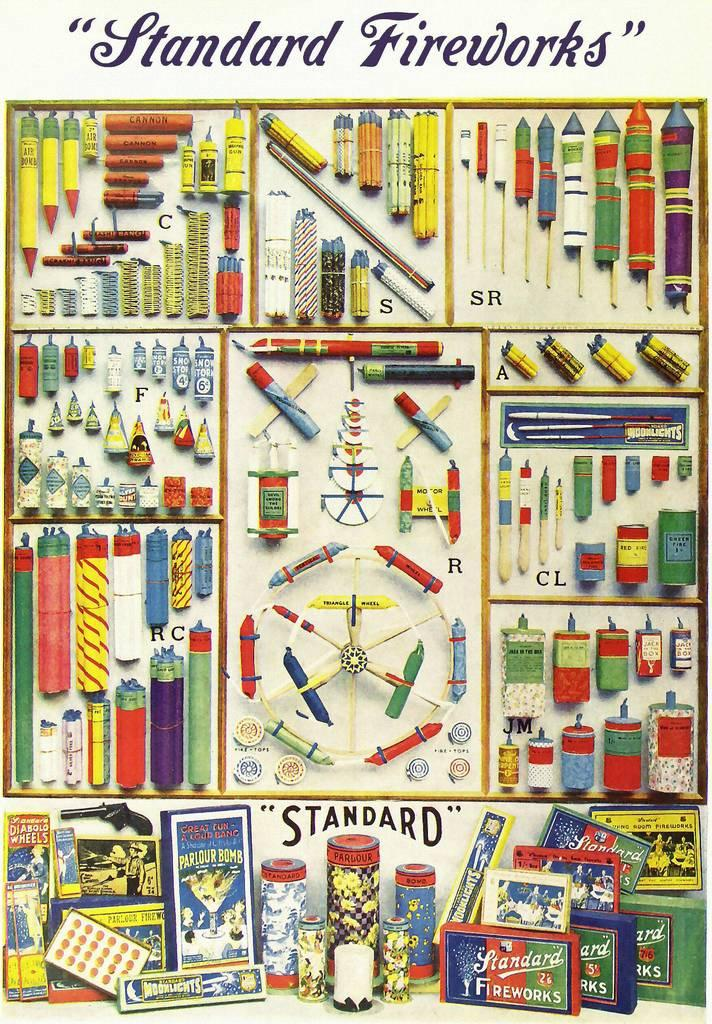Provide a one-sentence caption for the provided image. Standard is the brand of fireworks being solicited. 